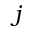<formula> <loc_0><loc_0><loc_500><loc_500>j</formula> 